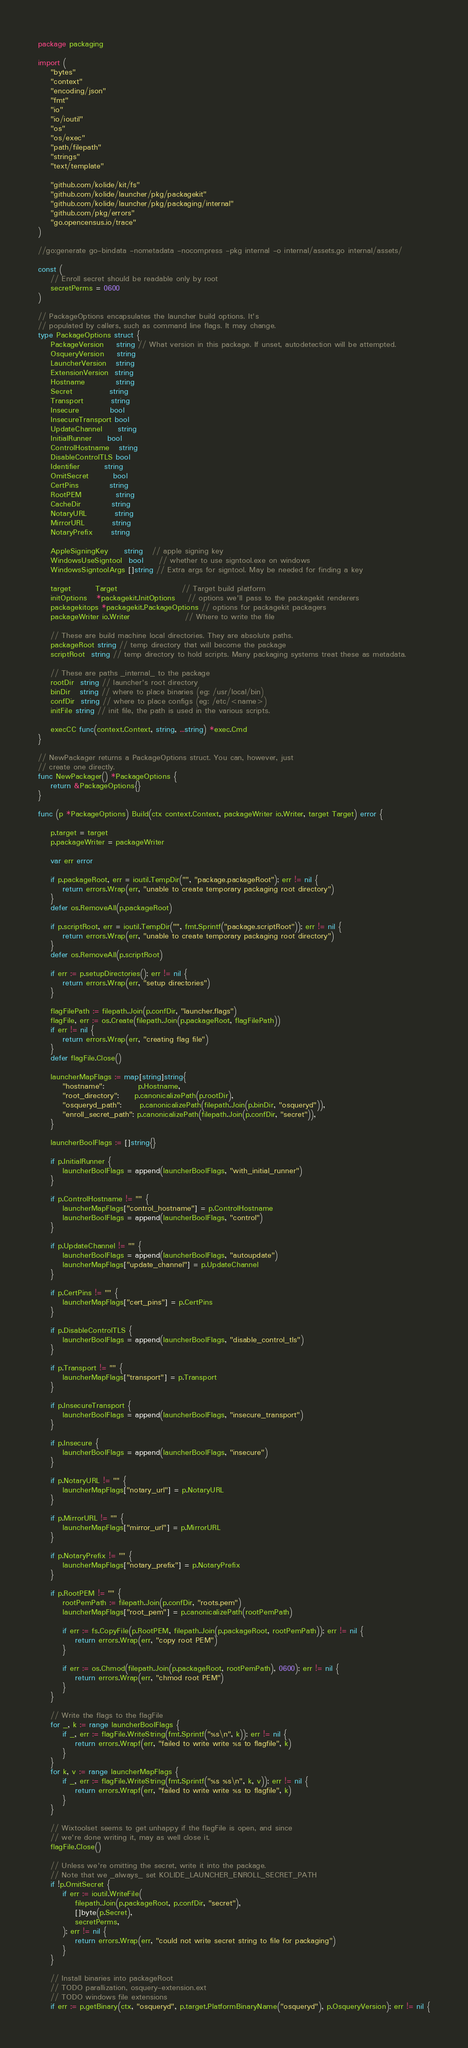<code> <loc_0><loc_0><loc_500><loc_500><_Go_>package packaging

import (
	"bytes"
	"context"
	"encoding/json"
	"fmt"
	"io"
	"io/ioutil"
	"os"
	"os/exec"
	"path/filepath"
	"strings"
	"text/template"

	"github.com/kolide/kit/fs"
	"github.com/kolide/launcher/pkg/packagekit"
	"github.com/kolide/launcher/pkg/packaging/internal"
	"github.com/pkg/errors"
	"go.opencensus.io/trace"
)

//go:generate go-bindata -nometadata -nocompress -pkg internal -o internal/assets.go internal/assets/

const (
	// Enroll secret should be readable only by root
	secretPerms = 0600
)

// PackageOptions encapsulates the launcher build options. It's
// populated by callers, such as command line flags. It may change.
type PackageOptions struct {
	PackageVersion    string // What version in this package. If unset, autodetection will be attempted.
	OsqueryVersion    string
	LauncherVersion   string
	ExtensionVersion  string
	Hostname          string
	Secret            string
	Transport         string
	Insecure          bool
	InsecureTransport bool
	UpdateChannel     string
	InitialRunner     bool
	ControlHostname   string
	DisableControlTLS bool
	Identifier        string
	OmitSecret        bool
	CertPins          string
	RootPEM           string
	CacheDir          string
	NotaryURL         string
	MirrorURL         string
	NotaryPrefix      string

	AppleSigningKey     string   // apple signing key
	WindowsUseSigntool  bool     // whether to use signtool.exe on windows
	WindowsSigntoolArgs []string // Extra args for signtool. May be needed for finding a key

	target        Target                     // Target build platform
	initOptions   *packagekit.InitOptions    // options we'll pass to the packagekit renderers
	packagekitops *packagekit.PackageOptions // options for packagekit packagers
	packageWriter io.Writer                  // Where to write the file

	// These are build machine local directories. They are absolute paths.
	packageRoot string // temp directory that will become the package
	scriptRoot  string // temp directory to hold scripts. Many packaging systems treat these as metadata.

	// These are paths _internal_ to the package
	rootDir  string // launcher's root directory
	binDir   string // where to place binaries (eg: /usr/local/bin)
	confDir  string // where to place configs (eg: /etc/<name>)
	initFile string // init file, the path is used in the various scripts.

	execCC func(context.Context, string, ...string) *exec.Cmd
}

// NewPackager returns a PackageOptions struct. You can, however, just
// create one directly.
func NewPackager() *PackageOptions {
	return &PackageOptions{}
}

func (p *PackageOptions) Build(ctx context.Context, packageWriter io.Writer, target Target) error {

	p.target = target
	p.packageWriter = packageWriter

	var err error

	if p.packageRoot, err = ioutil.TempDir("", "package.packageRoot"); err != nil {
		return errors.Wrap(err, "unable to create temporary packaging root directory")
	}
	defer os.RemoveAll(p.packageRoot)

	if p.scriptRoot, err = ioutil.TempDir("", fmt.Sprintf("package.scriptRoot")); err != nil {
		return errors.Wrap(err, "unable to create temporary packaging root directory")
	}
	defer os.RemoveAll(p.scriptRoot)

	if err := p.setupDirectories(); err != nil {
		return errors.Wrap(err, "setup directories")
	}

	flagFilePath := filepath.Join(p.confDir, "launcher.flags")
	flagFile, err := os.Create(filepath.Join(p.packageRoot, flagFilePath))
	if err != nil {
		return errors.Wrap(err, "creating flag file")
	}
	defer flagFile.Close()

	launcherMapFlags := map[string]string{
		"hostname":           p.Hostname,
		"root_directory":     p.canonicalizePath(p.rootDir),
		"osqueryd_path":      p.canonicalizePath(filepath.Join(p.binDir, "osqueryd")),
		"enroll_secret_path": p.canonicalizePath(filepath.Join(p.confDir, "secret")),
	}

	launcherBoolFlags := []string{}

	if p.InitialRunner {
		launcherBoolFlags = append(launcherBoolFlags, "with_initial_runner")
	}

	if p.ControlHostname != "" {
		launcherMapFlags["control_hostname"] = p.ControlHostname
		launcherBoolFlags = append(launcherBoolFlags, "control")
	}

	if p.UpdateChannel != "" {
		launcherBoolFlags = append(launcherBoolFlags, "autoupdate")
		launcherMapFlags["update_channel"] = p.UpdateChannel
	}

	if p.CertPins != "" {
		launcherMapFlags["cert_pins"] = p.CertPins
	}

	if p.DisableControlTLS {
		launcherBoolFlags = append(launcherBoolFlags, "disable_control_tls")
	}

	if p.Transport != "" {
		launcherMapFlags["transport"] = p.Transport
	}

	if p.InsecureTransport {
		launcherBoolFlags = append(launcherBoolFlags, "insecure_transport")
	}

	if p.Insecure {
		launcherBoolFlags = append(launcherBoolFlags, "insecure")
	}

	if p.NotaryURL != "" {
		launcherMapFlags["notary_url"] = p.NotaryURL
	}

	if p.MirrorURL != "" {
		launcherMapFlags["mirror_url"] = p.MirrorURL
	}

	if p.NotaryPrefix != "" {
		launcherMapFlags["notary_prefix"] = p.NotaryPrefix
	}

	if p.RootPEM != "" {
		rootPemPath := filepath.Join(p.confDir, "roots.pem")
		launcherMapFlags["root_pem"] = p.canonicalizePath(rootPemPath)

		if err := fs.CopyFile(p.RootPEM, filepath.Join(p.packageRoot, rootPemPath)); err != nil {
			return errors.Wrap(err, "copy root PEM")
		}

		if err := os.Chmod(filepath.Join(p.packageRoot, rootPemPath), 0600); err != nil {
			return errors.Wrap(err, "chmod root PEM")
		}
	}

	// Write the flags to the flagFile
	for _, k := range launcherBoolFlags {
		if _, err := flagFile.WriteString(fmt.Sprintf("%s\n", k)); err != nil {
			return errors.Wrapf(err, "failed to write write %s to flagfile", k)
		}
	}
	for k, v := range launcherMapFlags {
		if _, err := flagFile.WriteString(fmt.Sprintf("%s %s\n", k, v)); err != nil {
			return errors.Wrapf(err, "failed to write write %s to flagfile", k)
		}
	}

	// Wixtoolset seems to get unhappy if the flagFile is open, and since
	// we're done writing it, may as well close it.
	flagFile.Close()

	// Unless we're omitting the secret, write it into the package.
	// Note that we _always_ set KOLIDE_LAUNCHER_ENROLL_SECRET_PATH
	if !p.OmitSecret {
		if err := ioutil.WriteFile(
			filepath.Join(p.packageRoot, p.confDir, "secret"),
			[]byte(p.Secret),
			secretPerms,
		); err != nil {
			return errors.Wrap(err, "could not write secret string to file for packaging")
		}
	}

	// Install binaries into packageRoot
	// TODO parallization, osquery-extension.ext
	// TODO windows file extensions
	if err := p.getBinary(ctx, "osqueryd", p.target.PlatformBinaryName("osqueryd"), p.OsqueryVersion); err != nil {</code> 